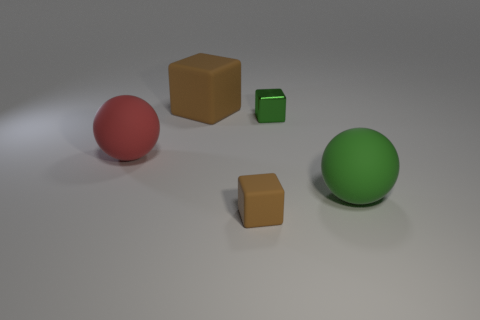Subtract all shiny cubes. How many cubes are left? 2 Subtract all green spheres. How many brown cubes are left? 2 Add 4 large things. How many objects exist? 9 Subtract all balls. How many objects are left? 3 Add 5 small purple blocks. How many small purple blocks exist? 5 Subtract 0 cyan cubes. How many objects are left? 5 Subtract all large cyan matte spheres. Subtract all cubes. How many objects are left? 2 Add 3 large brown cubes. How many large brown cubes are left? 4 